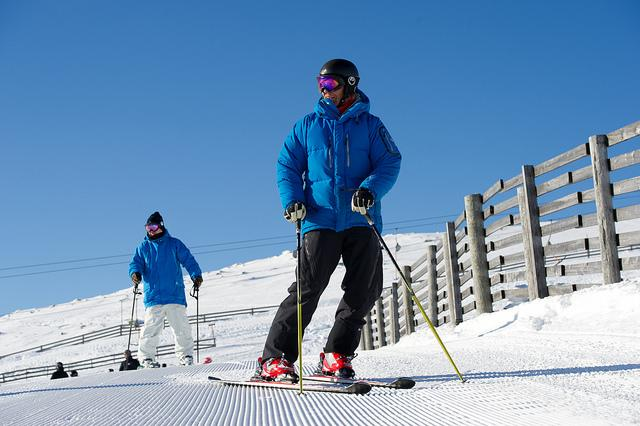What made the grooves seen here? Please explain your reasoning. snow groomer. The lines are too perfect to be man made, so it must have been the groomer. 